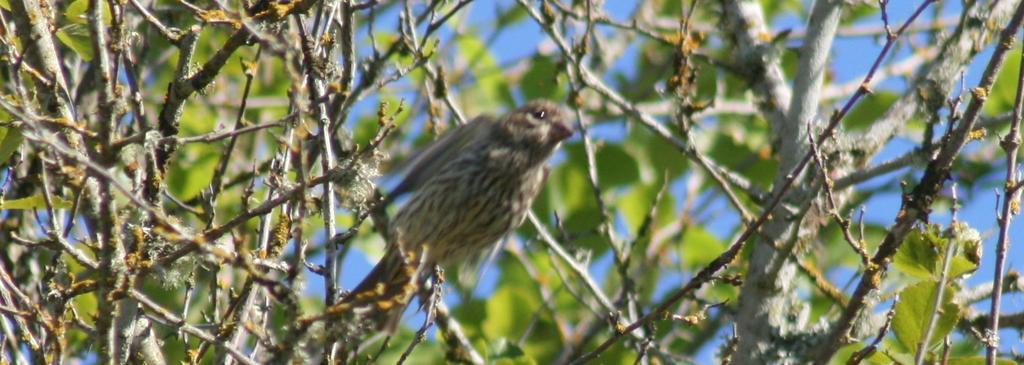In one or two sentences, can you explain what this image depicts? In this image there are trees truncated, there is a bird on the tree, in the background of the image there is the sky. 